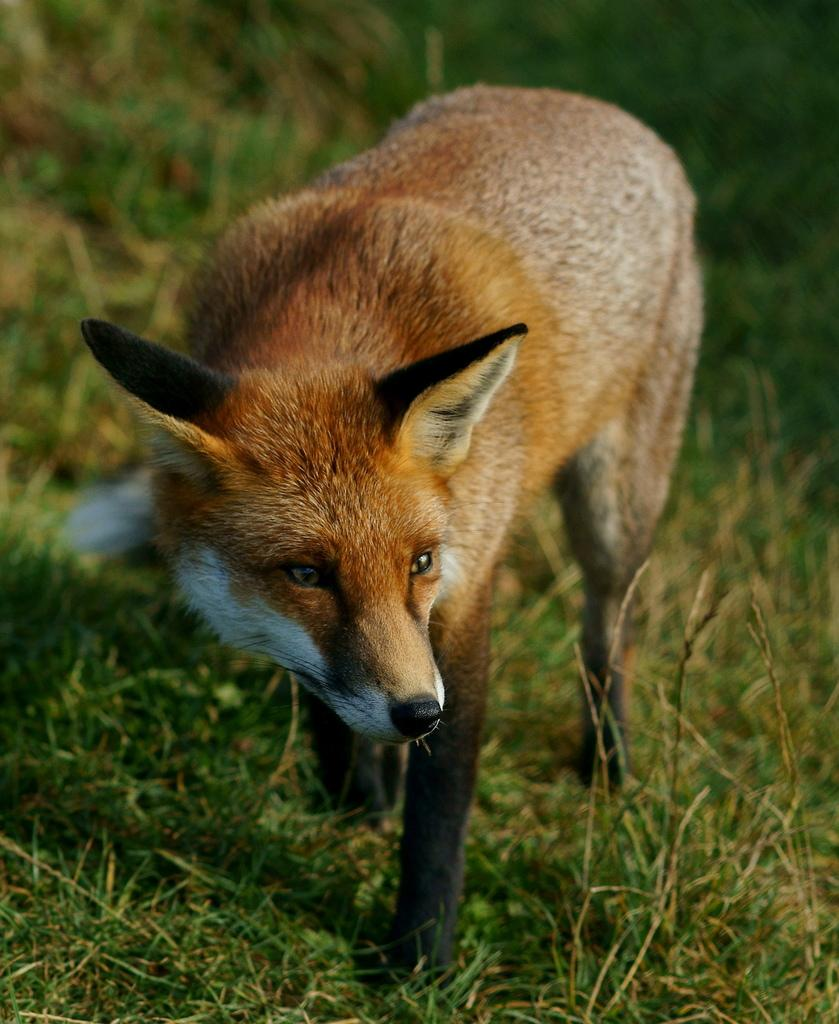What type of creature is in the image? There is an animal in the image. What is the animal standing on? The animal is standing on the grass. Can you describe the coloring of the animal? The animal has black and brown coloring. What color is the grass in the image? The grass is green in color. How many friends does the bear have in the image? There is no bear present in the image, and therefore no friends to count. What role does the father play in the image? There is no mention of a father or any human figures in the image, so it is not possible to determine their role. 